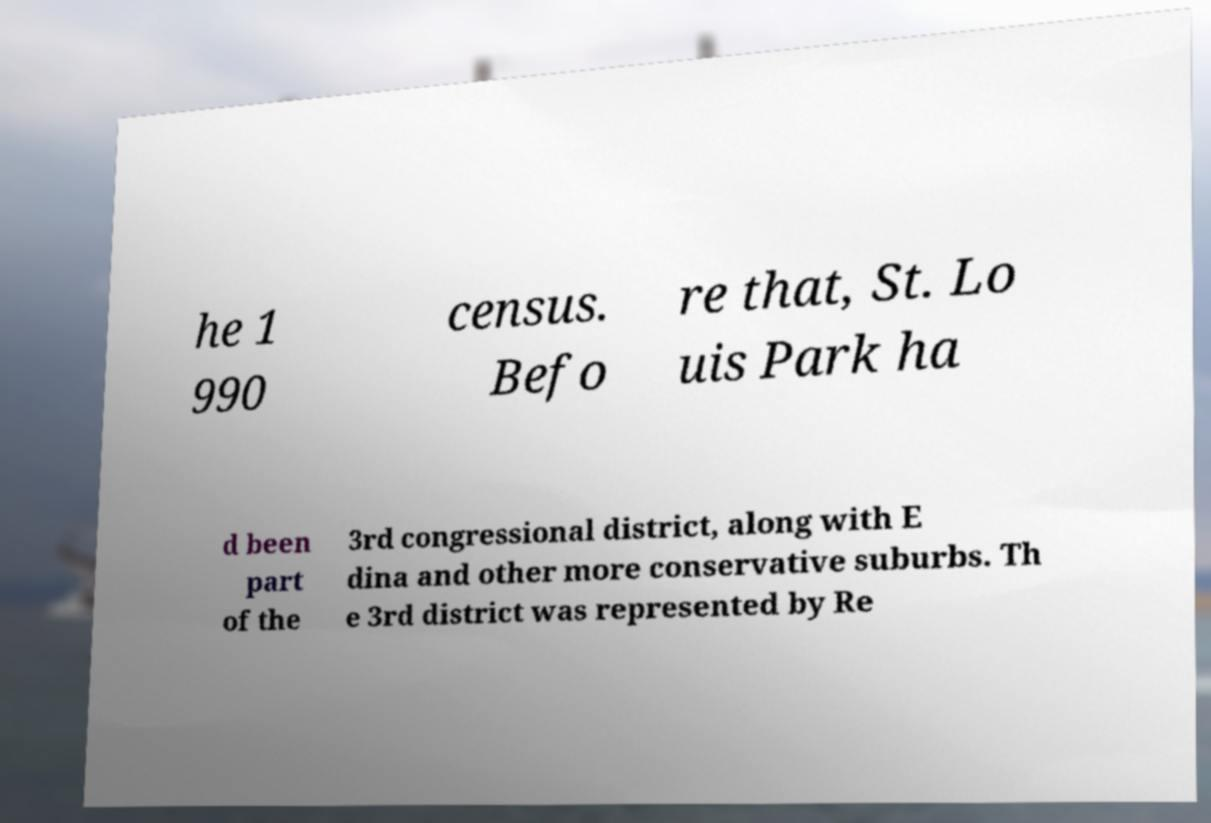For documentation purposes, I need the text within this image transcribed. Could you provide that? he 1 990 census. Befo re that, St. Lo uis Park ha d been part of the 3rd congressional district, along with E dina and other more conservative suburbs. Th e 3rd district was represented by Re 